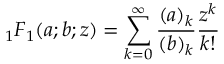<formula> <loc_0><loc_0><loc_500><loc_500>{ _ { 1 } F _ { 1 } } ( a ; b ; z ) = \sum _ { k = 0 } ^ { \infty } \frac { ( a ) _ { k } } { ( b ) _ { k } } \frac { z ^ { k } } { k ! }</formula> 